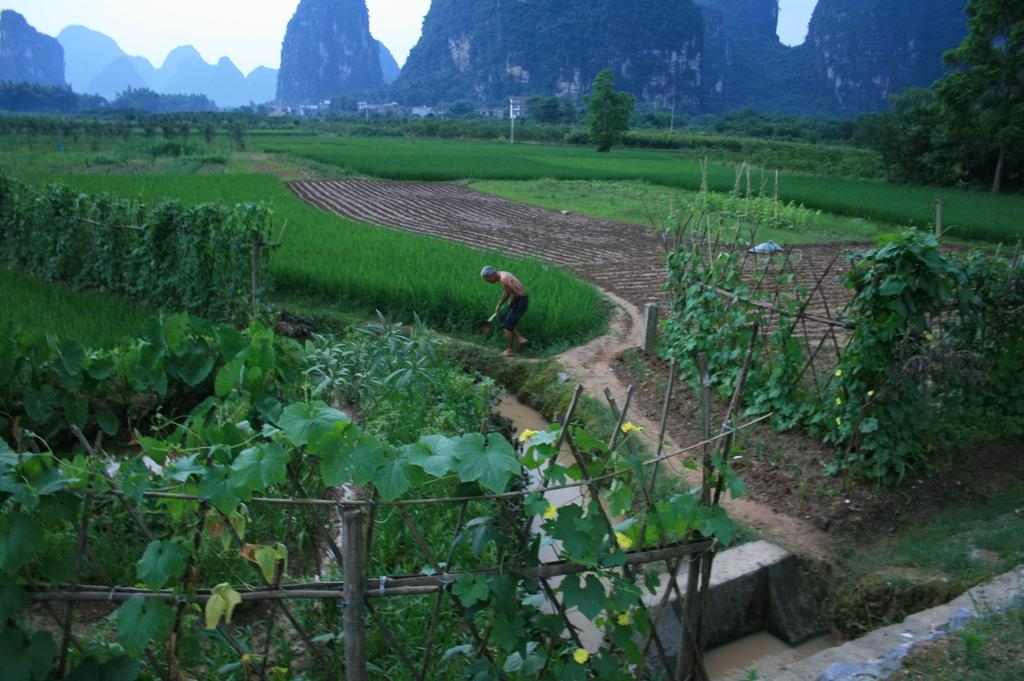Who is the main subject in the image? There is a farmer in the center of the image. What can be seen in the surroundings of the image? There is greenery around the area of the image. What is present at the bottom side of the image? There is a boundary at the bottom side of the image. What type of pie is being baked by the farmer in the image? There is no pie present in the image, nor is the farmer engaged in any baking activity. 